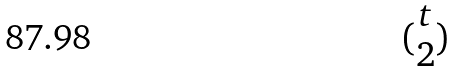Convert formula to latex. <formula><loc_0><loc_0><loc_500><loc_500>( \begin{matrix} t \\ 2 \end{matrix} )</formula> 